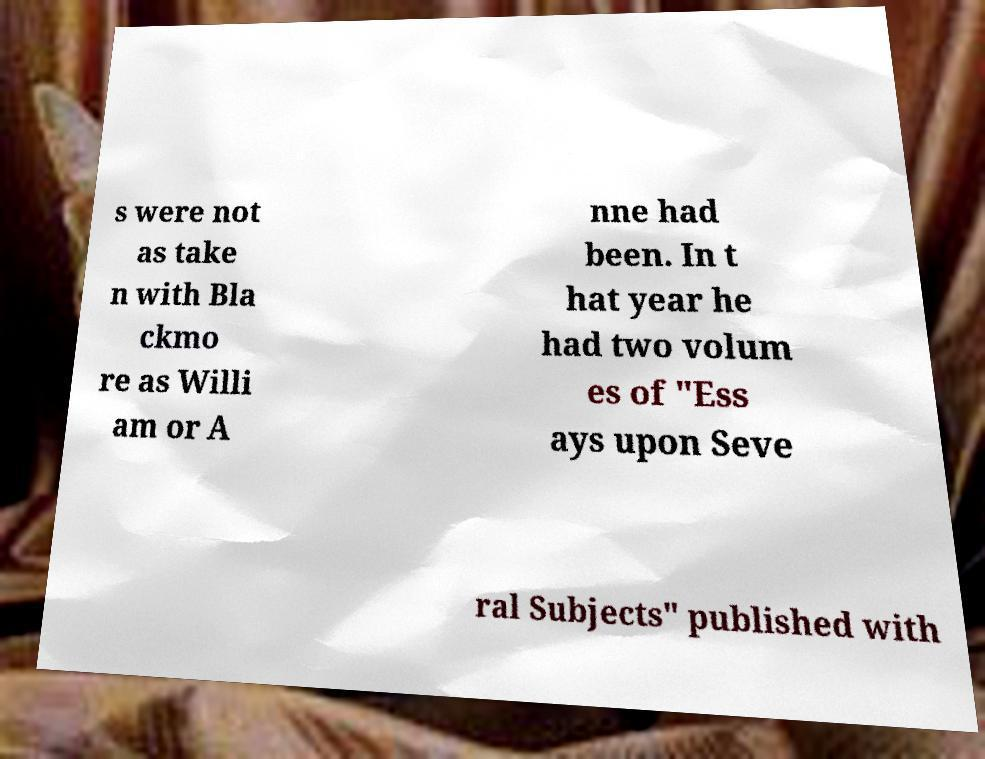There's text embedded in this image that I need extracted. Can you transcribe it verbatim? s were not as take n with Bla ckmo re as Willi am or A nne had been. In t hat year he had two volum es of "Ess ays upon Seve ral Subjects" published with 